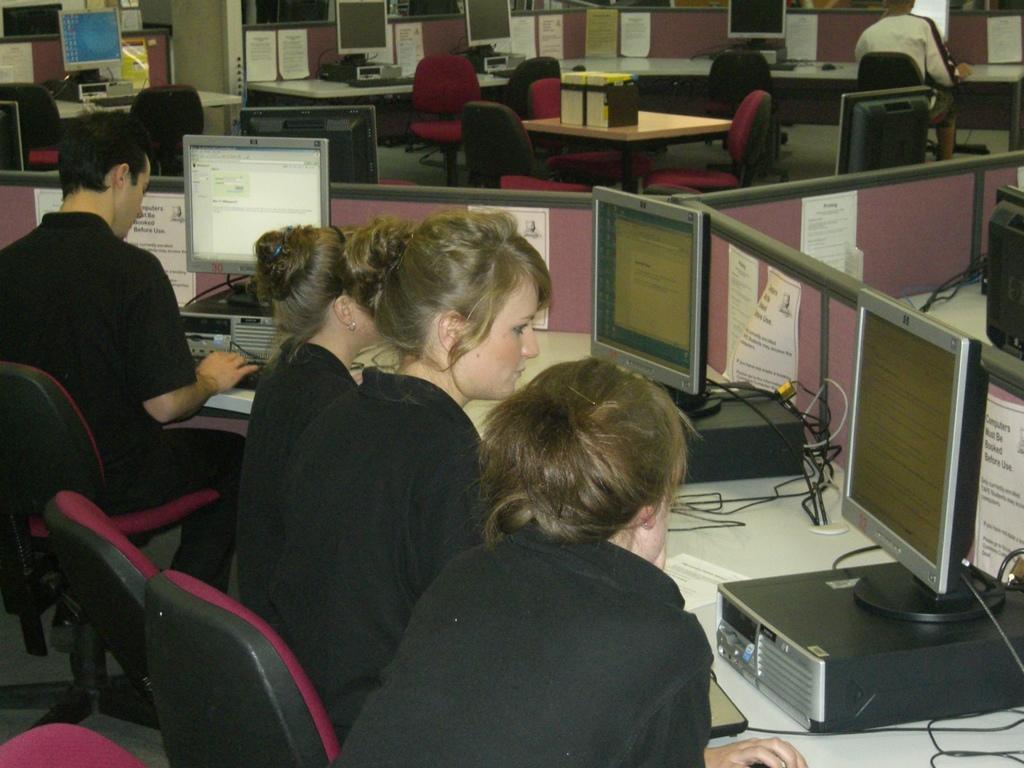In one or two sentences, can you explain what this image depicts? In this image we can see cabins. People are sitting and working on the computers. At the top of the image, we can see chairs, table, papers, monitors and one file holder. 